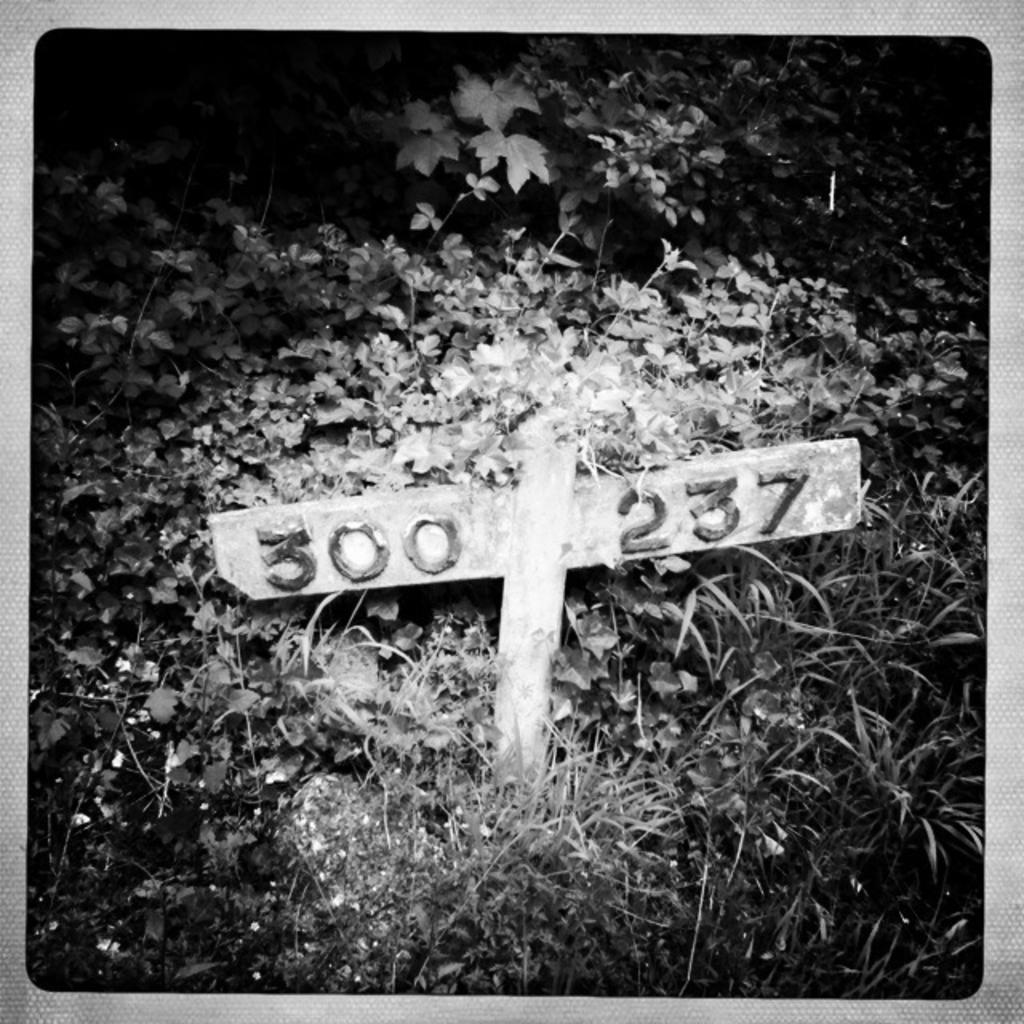<image>
Render a clear and concise summary of the photo. Two pieces of wood form a rudimentary sign noting the numbers "300 237" in the foliage. 